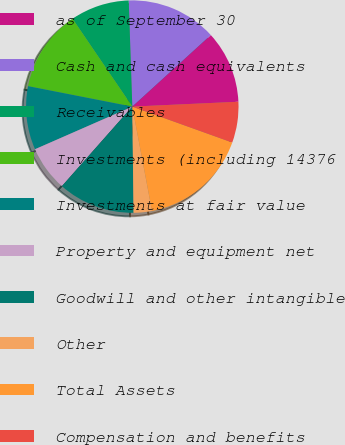<chart> <loc_0><loc_0><loc_500><loc_500><pie_chart><fcel>as of September 30<fcel>Cash and cash equivalents<fcel>Receivables<fcel>Investments (including 14376<fcel>Investments at fair value<fcel>Property and equipment net<fcel>Goodwill and other intangible<fcel>Other<fcel>Total Assets<fcel>Compensation and benefits<nl><fcel>11.03%<fcel>13.78%<fcel>8.97%<fcel>12.41%<fcel>9.66%<fcel>6.9%<fcel>11.72%<fcel>2.78%<fcel>16.54%<fcel>6.22%<nl></chart> 